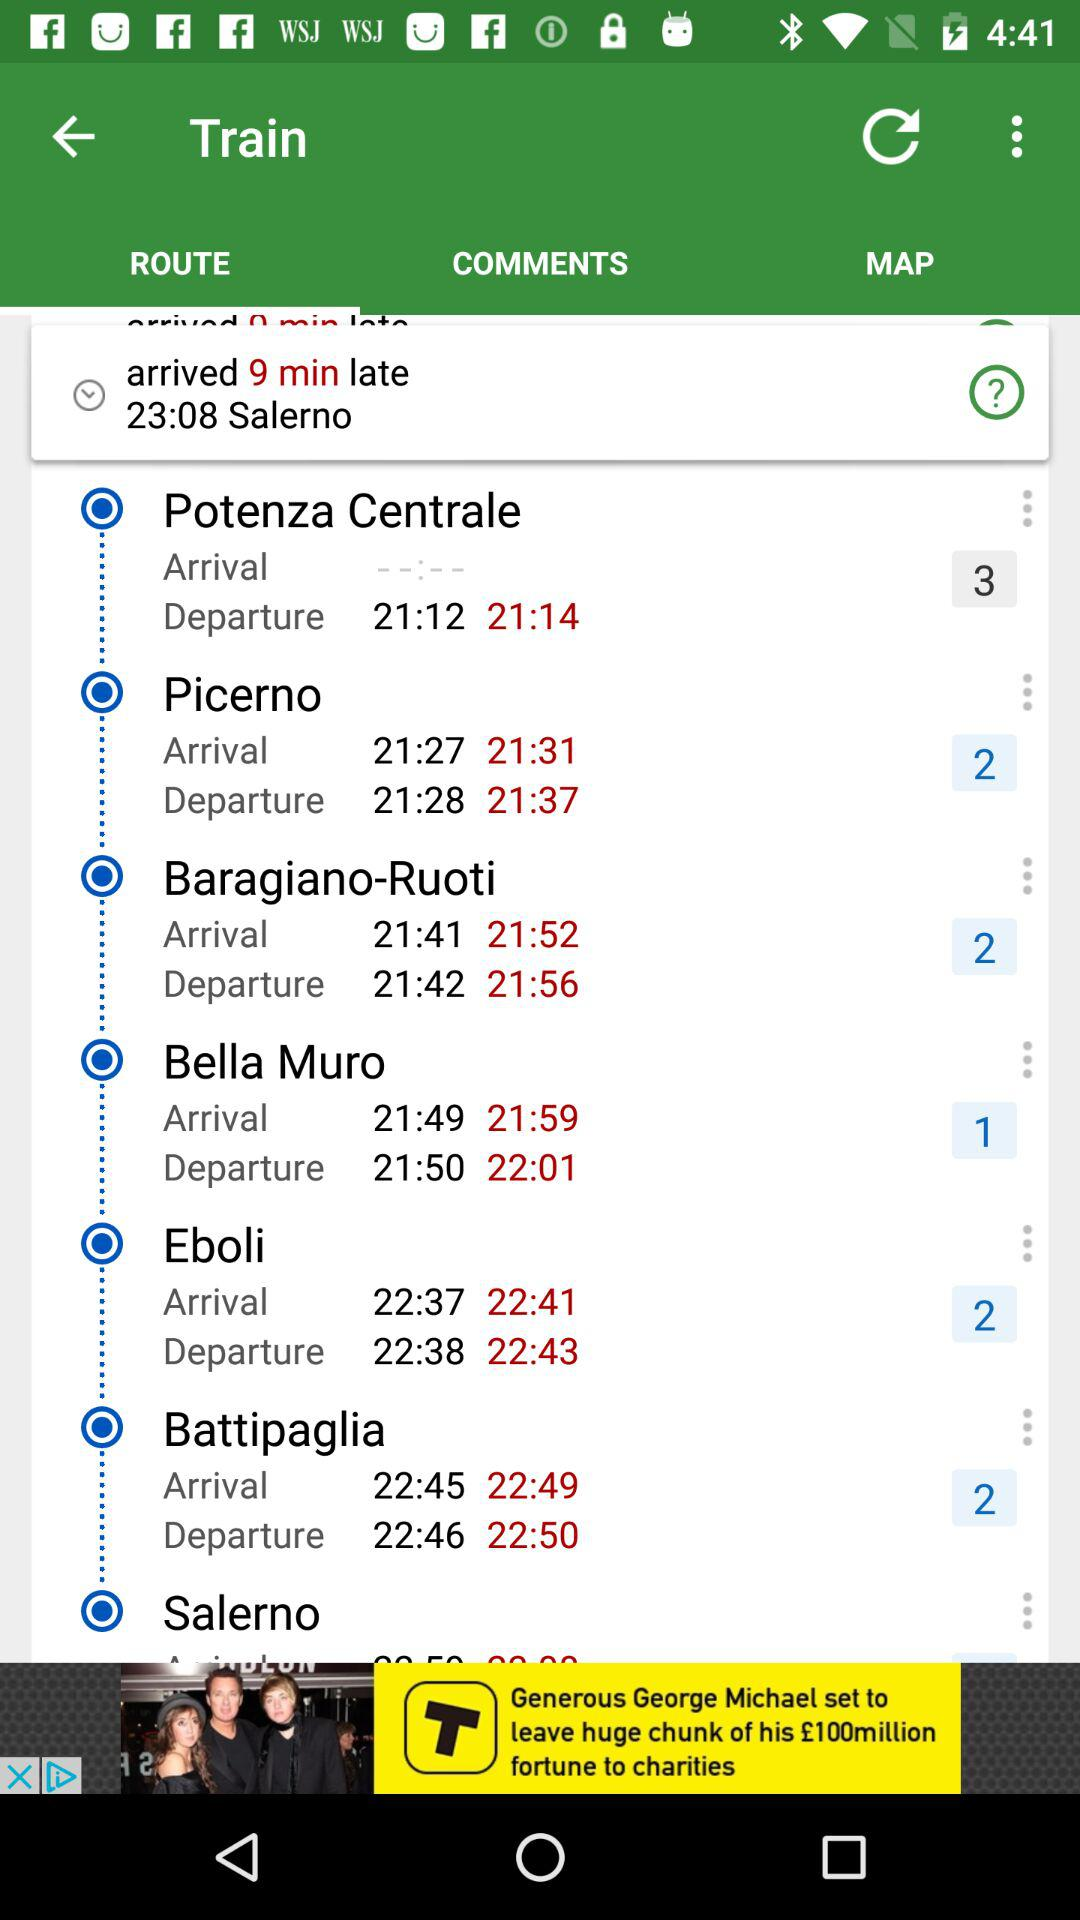Which station does not have an arrival time? The station that does not have an arrival time is "Potenza Centrale". 